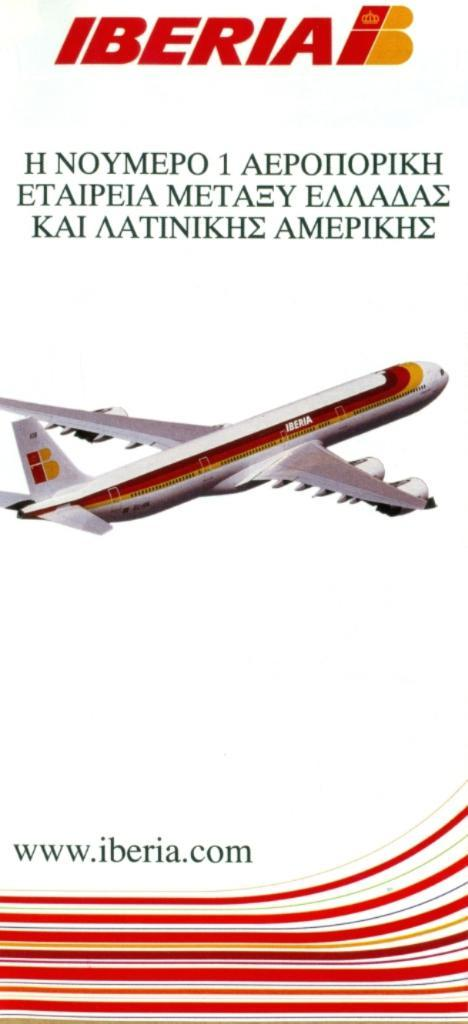<image>
Give a short and clear explanation of the subsequent image. Plane that is located in iberia with a brochure of the plane 